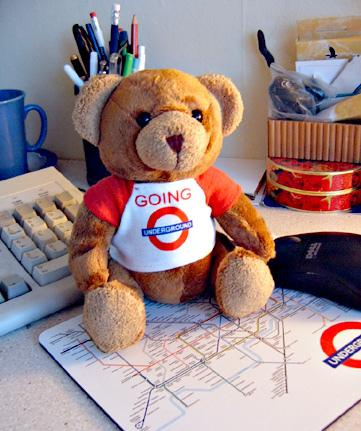What color is the big circular ring in the logo of the bear's t-shirt? Please explain your reasoning. red. This is obviously the color. 